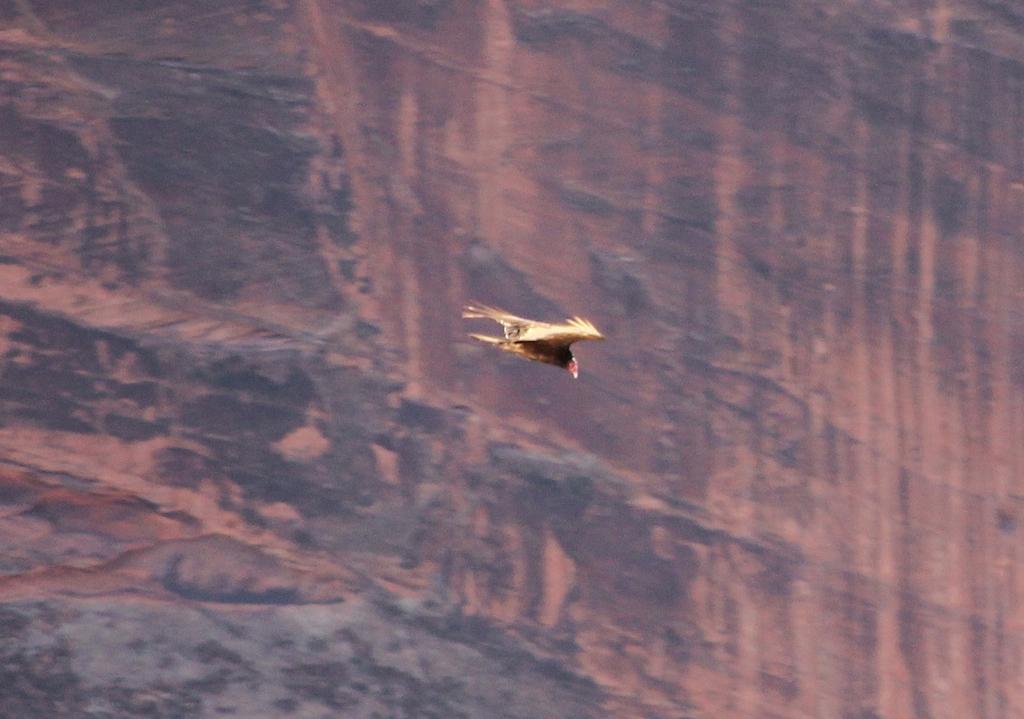Please provide a concise description of this image. In this picture there is a bird in the center. It is in brown in color. In the background there is a rock hill. 